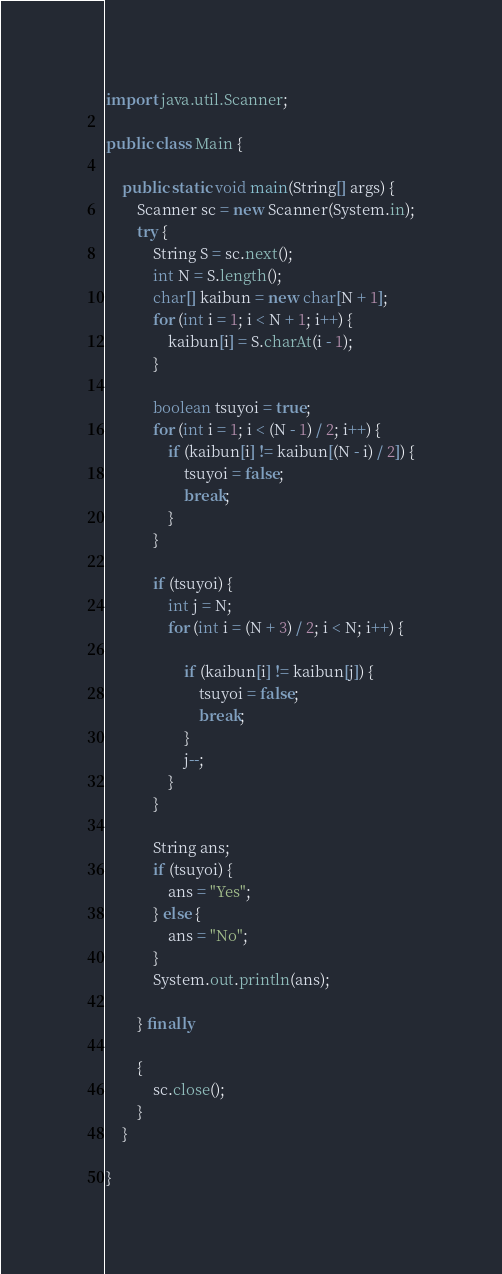Convert code to text. <code><loc_0><loc_0><loc_500><loc_500><_Java_>import java.util.Scanner;

public class Main {

	public static void main(String[] args) {
		Scanner sc = new Scanner(System.in);
		try {
			String S = sc.next();
			int N = S.length();
			char[] kaibun = new char[N + 1];
			for (int i = 1; i < N + 1; i++) {
				kaibun[i] = S.charAt(i - 1);
			}

			boolean tsuyoi = true;
			for (int i = 1; i < (N - 1) / 2; i++) {
				if (kaibun[i] != kaibun[(N - i) / 2]) {
					tsuyoi = false;
					break;
				}
			}

			if (tsuyoi) {
				int j = N;
				for (int i = (N + 3) / 2; i < N; i++) {

					if (kaibun[i] != kaibun[j]) {
						tsuyoi = false;
						break;
					}
					j--;
				}
			}

			String ans;
			if (tsuyoi) {
				ans = "Yes";
			} else {
				ans = "No";
			}
			System.out.println(ans);

		} finally

		{
			sc.close();
		}
	}

}
</code> 